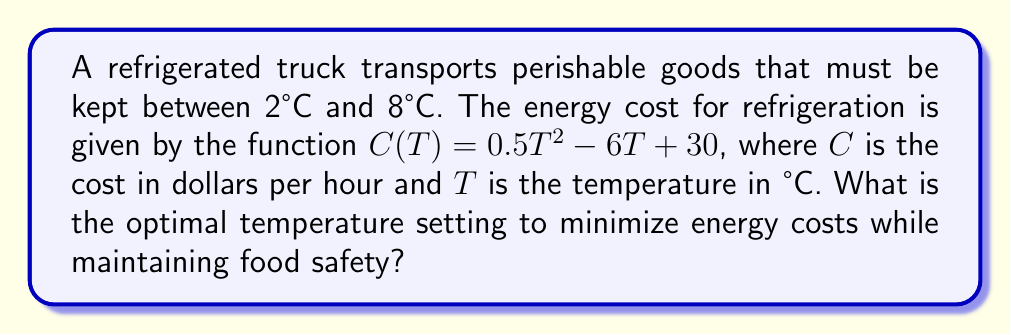Provide a solution to this math problem. To solve this problem, we follow these steps:

1) The cost function is quadratic: $C(T) = 0.5T^2 - 6T + 30$

2) To find the minimum of this function, we need to find where its derivative equals zero:
   
   $\frac{dC}{dT} = T - 6$
   
   Set this equal to zero:
   $T - 6 = 0$
   $T = 6$

3) The second derivative is positive ($\frac{d^2C}{dT^2} = 1 > 0$), confirming this is a minimum.

4) However, we need to check if this minimum falls within our acceptable range of 2°C to 8°C.

5) Since 6°C is within this range, it is our optimal temperature.

6) To verify:
   At 5°C: $C(5) = 0.5(5)^2 - 6(5) + 30 = 17.5$
   At 6°C: $C(6) = 0.5(6)^2 - 6(6) + 30 = 12$
   At 7°C: $C(7) = 0.5(7)^2 - 6(7) + 30 = 12.5$

   This confirms 6°C is indeed the minimum within our range.
Answer: 6°C 